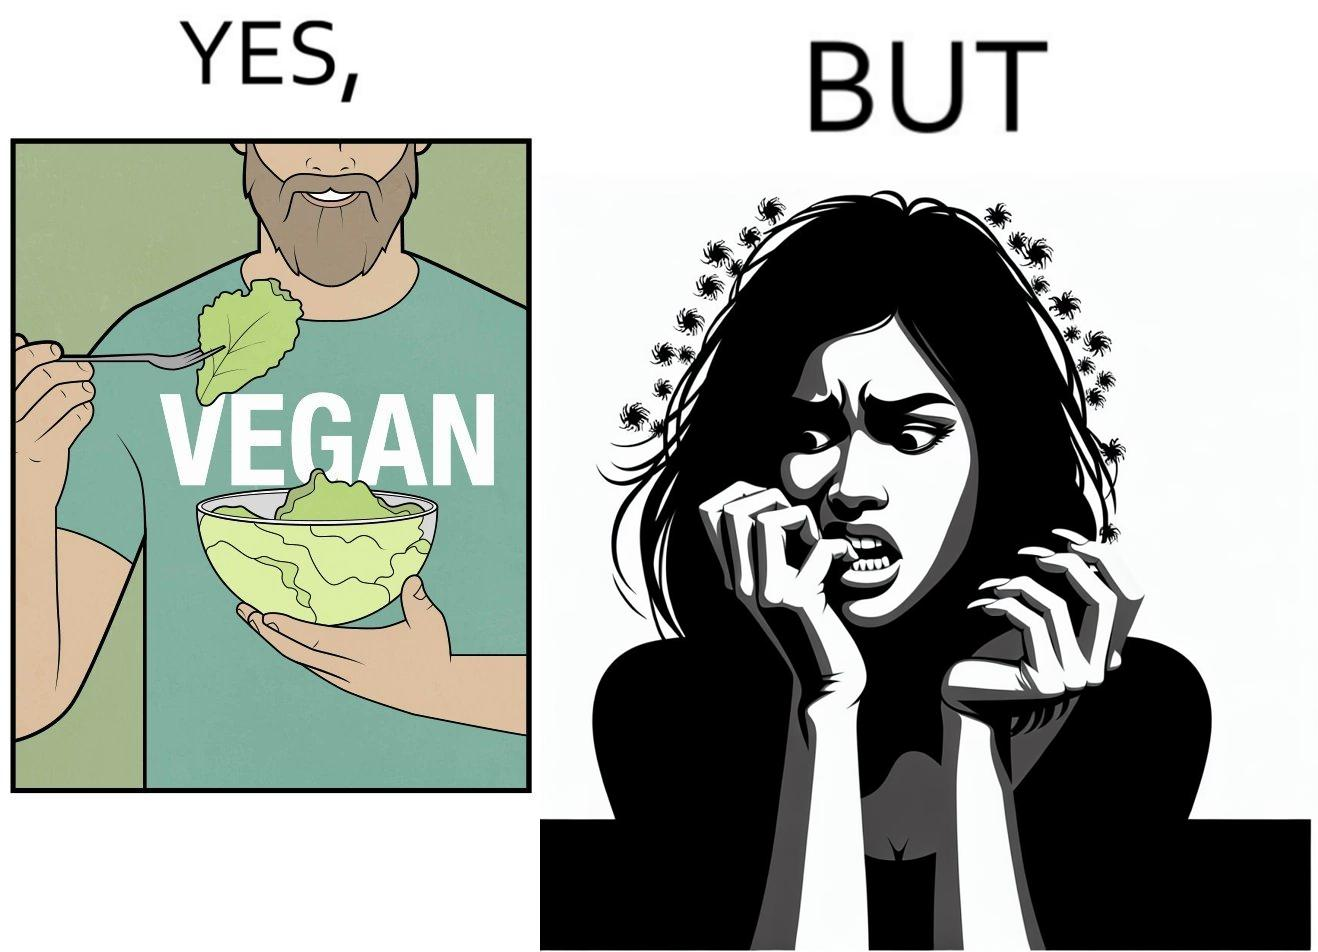Would you classify this image as satirical? Yes, this image is satirical. 